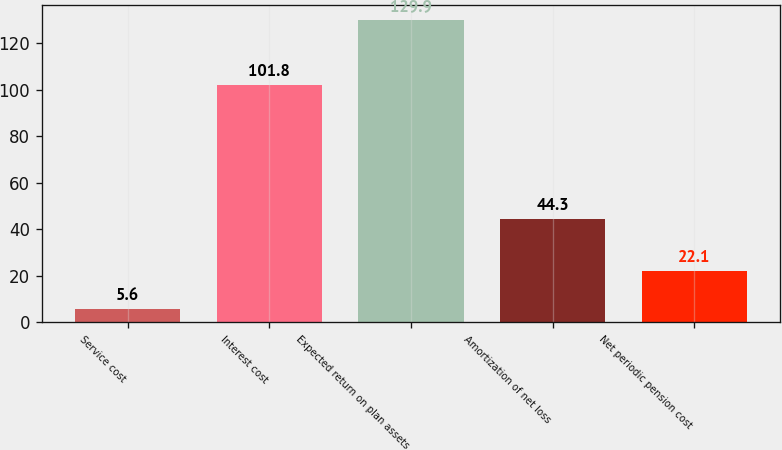Convert chart. <chart><loc_0><loc_0><loc_500><loc_500><bar_chart><fcel>Service cost<fcel>Interest cost<fcel>Expected return on plan assets<fcel>Amortization of net loss<fcel>Net periodic pension cost<nl><fcel>5.6<fcel>101.8<fcel>129.9<fcel>44.3<fcel>22.1<nl></chart> 